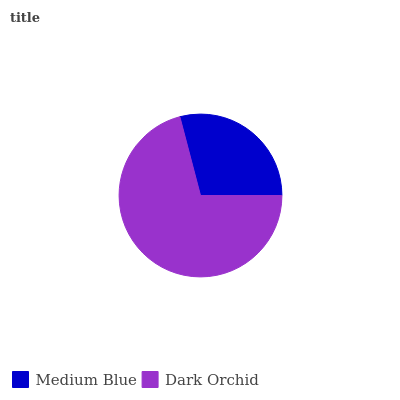Is Medium Blue the minimum?
Answer yes or no. Yes. Is Dark Orchid the maximum?
Answer yes or no. Yes. Is Dark Orchid the minimum?
Answer yes or no. No. Is Dark Orchid greater than Medium Blue?
Answer yes or no. Yes. Is Medium Blue less than Dark Orchid?
Answer yes or no. Yes. Is Medium Blue greater than Dark Orchid?
Answer yes or no. No. Is Dark Orchid less than Medium Blue?
Answer yes or no. No. Is Dark Orchid the high median?
Answer yes or no. Yes. Is Medium Blue the low median?
Answer yes or no. Yes. Is Medium Blue the high median?
Answer yes or no. No. Is Dark Orchid the low median?
Answer yes or no. No. 